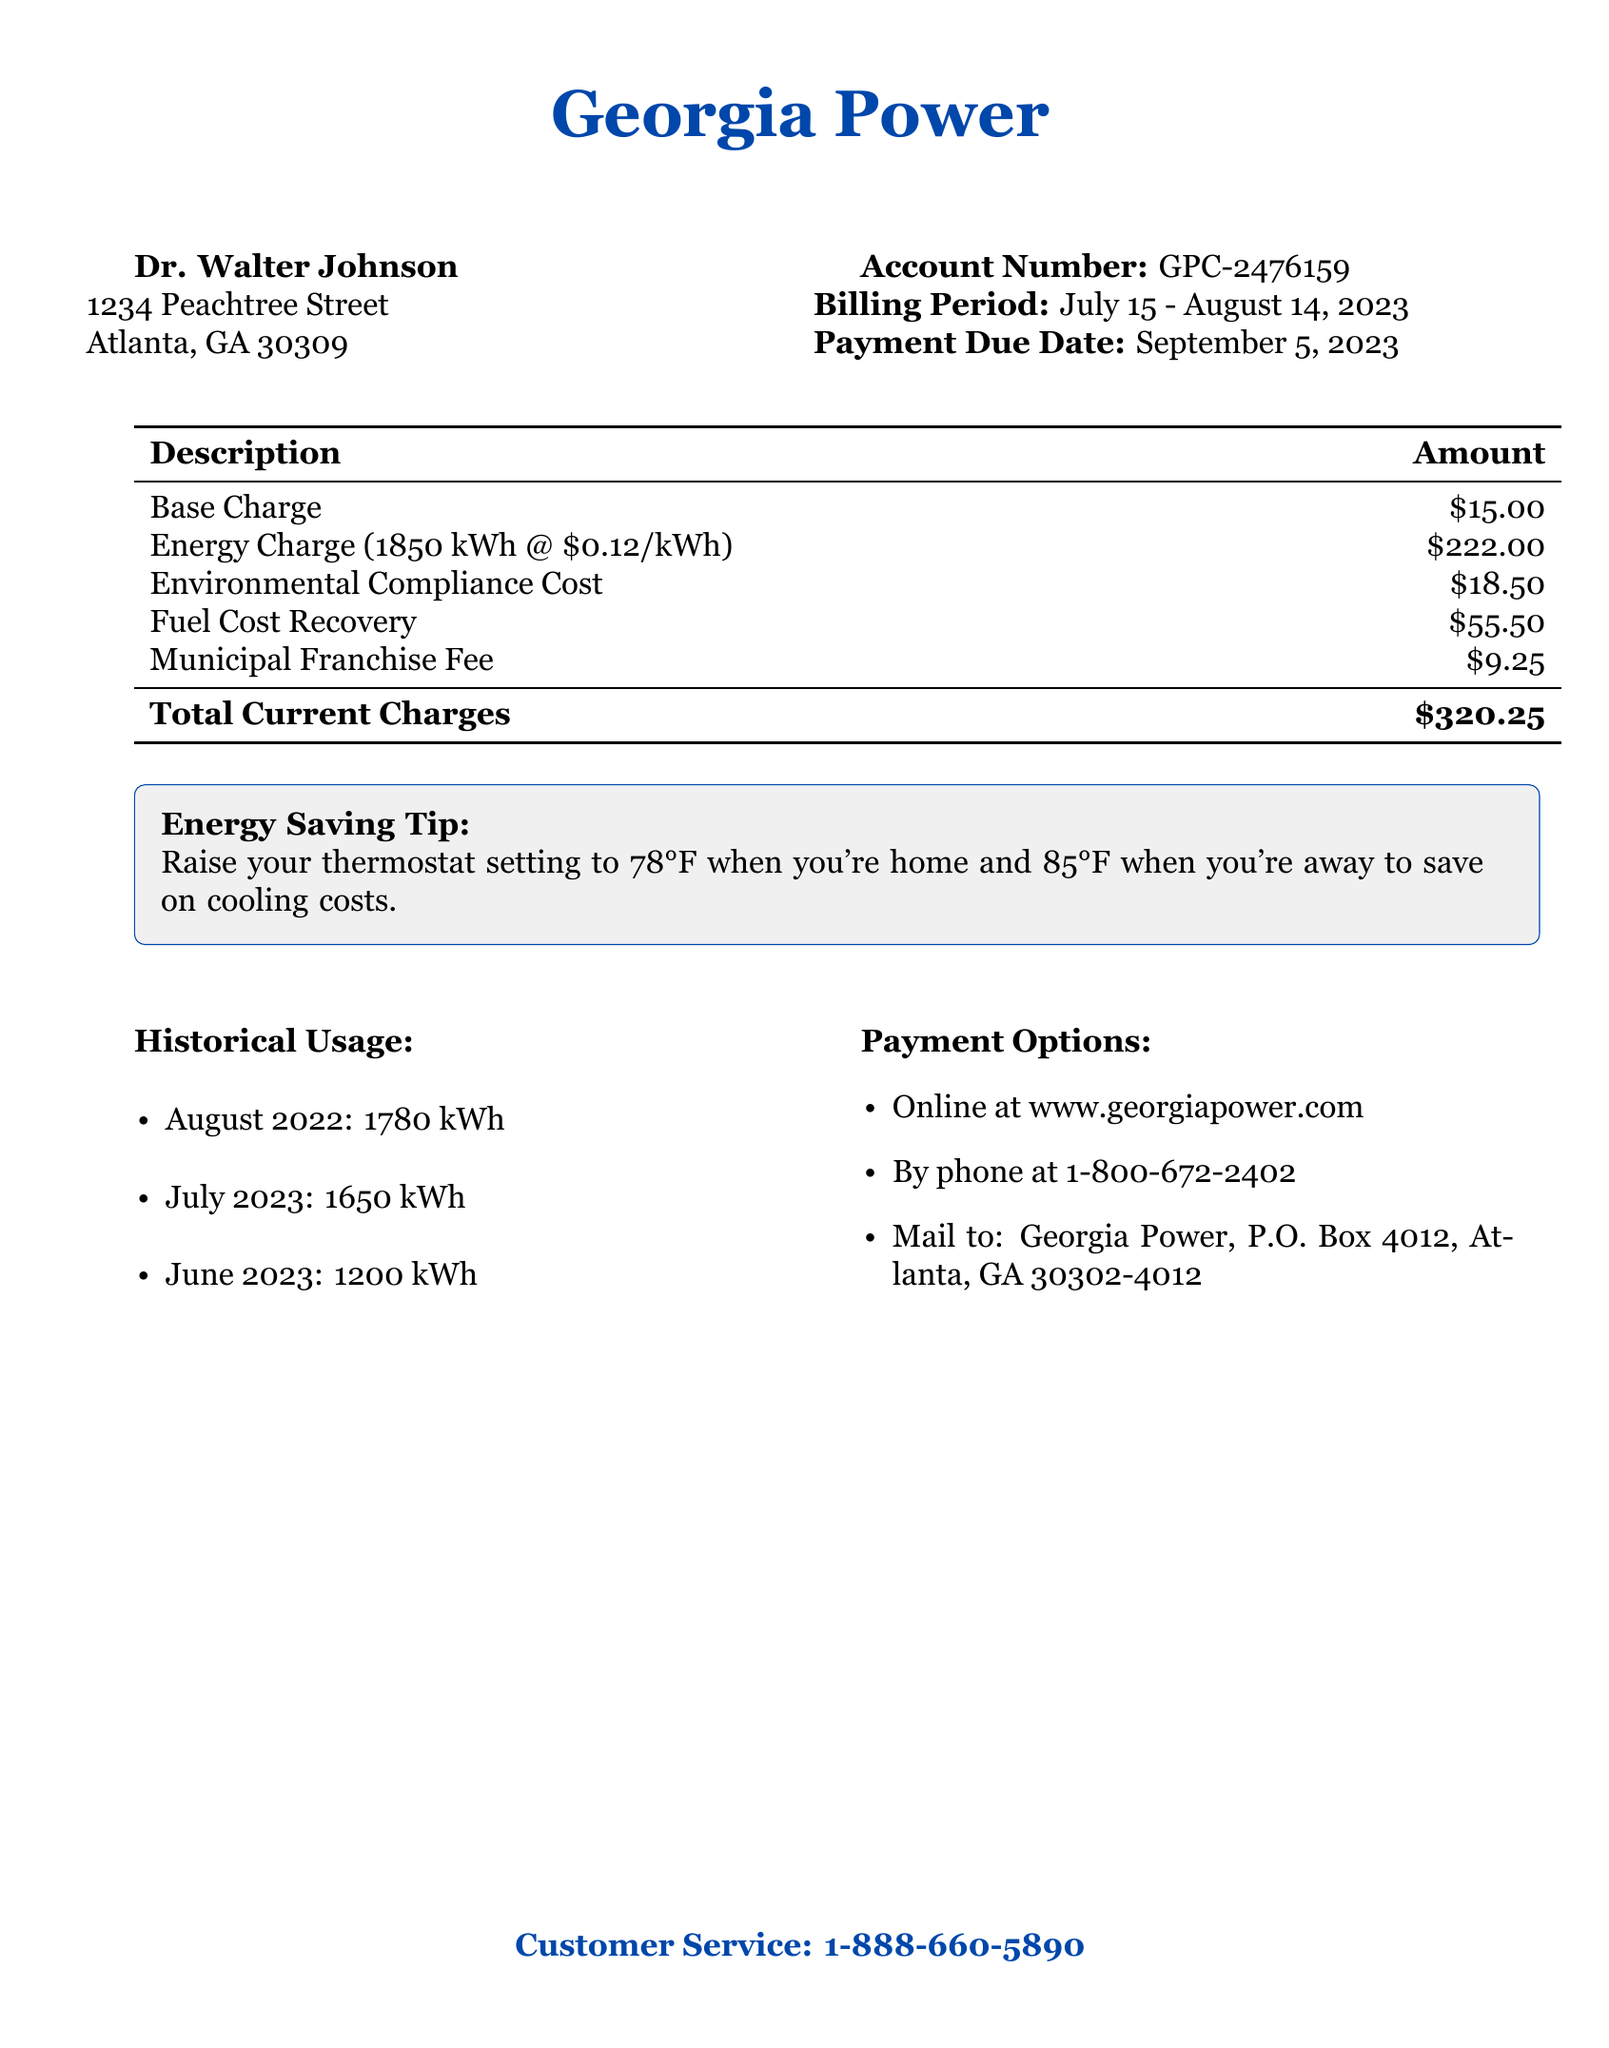What is the total current charges? The total current charges are outlined at the bottom of the charges table, which is $320.25.
Answer: $320.25 What is the account number? The account number is provided in the document for identification, which is GPC-2476159.
Answer: GPC-2476159 What is the billing period? The billing period is specified in the document from July 15 to August 14, 2023.
Answer: July 15 - August 14, 2023 How much was the energy charge for this period? The energy charge can be found in the charges breakdown, which lists it as $222.00.
Answer: $222.00 What was the historical usage for August 2022? The historical usage for August 2022 is listed in the document as 1780 kWh.
Answer: 1780 kWh Was the current energy usage higher or lower than previous months? To determine this, compare the current month's usage (1850 kWh) to previous months; it is higher than the previous months listed.
Answer: Higher How can customers pay their bill? Payment options are provided in a list format which includes online, by phone, and by mail.
Answer: Online, by phone, by mail What is the suggested thermostat setting when home? The energy-saving tip includes a recommended thermostat setting, which is 78°F when home.
Answer: 78°F What is the payment due date? The payment due date is stated in the document, which is September 5, 2023.
Answer: September 5, 2023 